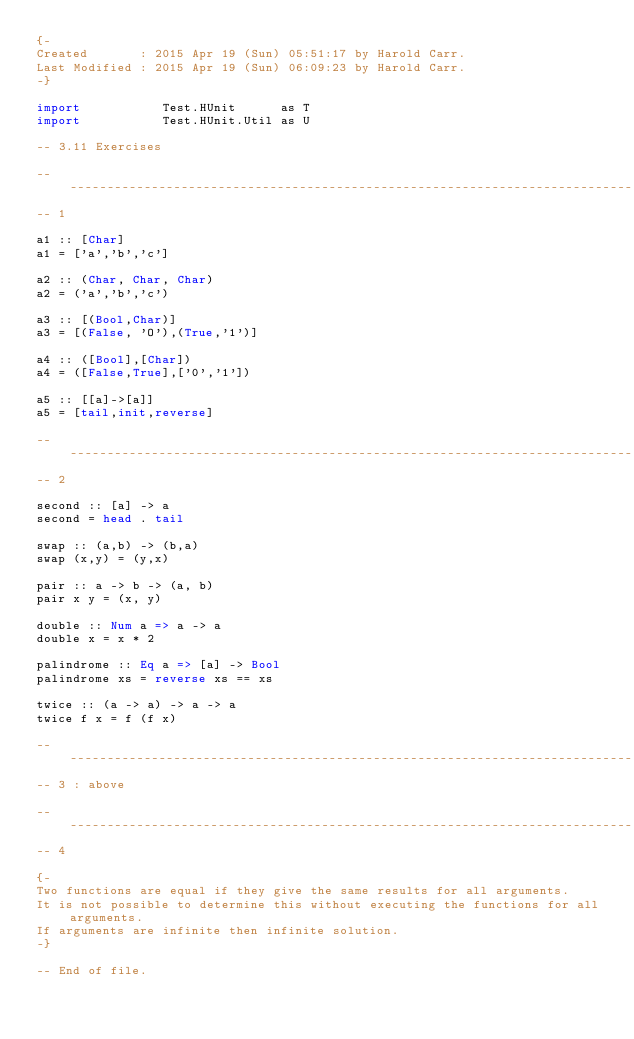<code> <loc_0><loc_0><loc_500><loc_500><_Haskell_>{-
Created       : 2015 Apr 19 (Sun) 05:51:17 by Harold Carr.
Last Modified : 2015 Apr 19 (Sun) 06:09:23 by Harold Carr.
-}

import           Test.HUnit      as T
import           Test.HUnit.Util as U

-- 3.11 Exercises

------------------------------------------------------------------------------
-- 1

a1 :: [Char]
a1 = ['a','b','c']

a2 :: (Char, Char, Char)
a2 = ('a','b','c')

a3 :: [(Bool,Char)]
a3 = [(False, 'O'),(True,'1')]

a4 :: ([Bool],[Char])
a4 = ([False,True],['0','1'])

a5 :: [[a]->[a]]
a5 = [tail,init,reverse]

------------------------------------------------------------------------------
-- 2

second :: [a] -> a
second = head . tail

swap :: (a,b) -> (b,a)
swap (x,y) = (y,x)

pair :: a -> b -> (a, b)
pair x y = (x, y)

double :: Num a => a -> a
double x = x * 2

palindrome :: Eq a => [a] -> Bool
palindrome xs = reverse xs == xs

twice :: (a -> a) -> a -> a
twice f x = f (f x)

------------------------------------------------------------------------------
-- 3 : above

------------------------------------------------------------------------------
-- 4

{-
Two functions are equal if they give the same results for all arguments.
It is not possible to determine this without executing the functions for all arguments.
If arguments are infinite then infinite solution.
-}

-- End of file.
</code> 